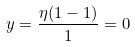Convert formula to latex. <formula><loc_0><loc_0><loc_500><loc_500>y = \frac { \eta ( 1 - 1 ) } { 1 } = 0</formula> 